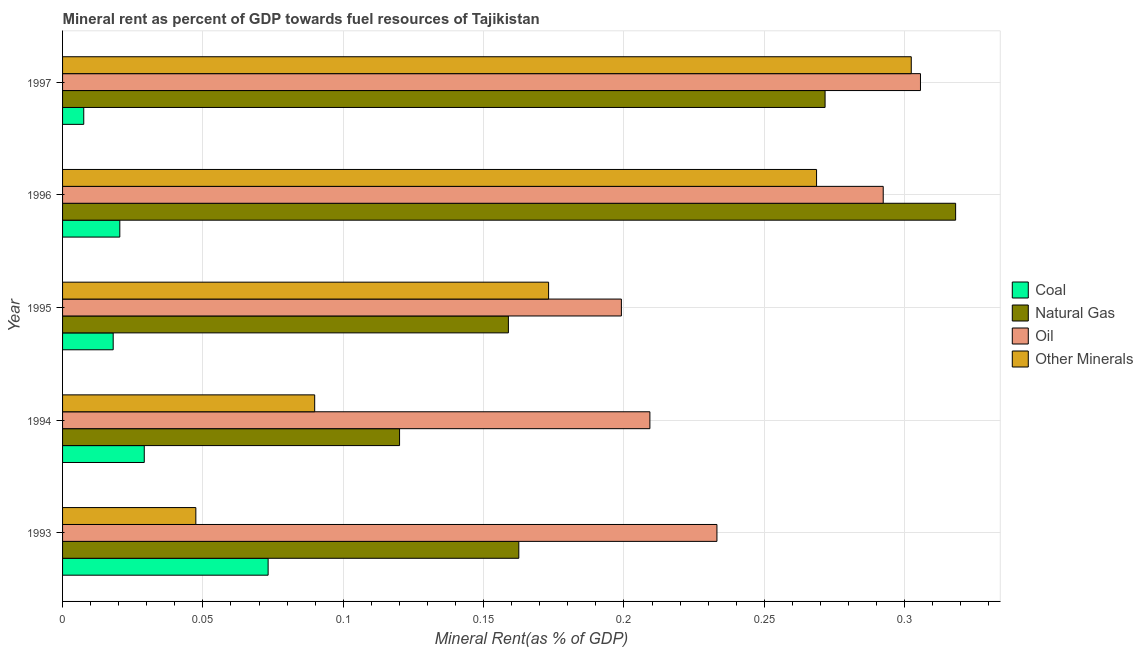How many groups of bars are there?
Your answer should be very brief. 5. Are the number of bars per tick equal to the number of legend labels?
Offer a very short reply. Yes. What is the oil rent in 1994?
Keep it short and to the point. 0.21. Across all years, what is the maximum  rent of other minerals?
Your answer should be very brief. 0.3. Across all years, what is the minimum oil rent?
Provide a succinct answer. 0.2. What is the total coal rent in the graph?
Your response must be concise. 0.15. What is the difference between the  rent of other minerals in 1993 and that in 1997?
Offer a terse response. -0.26. What is the difference between the natural gas rent in 1997 and the coal rent in 1996?
Your answer should be very brief. 0.25. What is the average natural gas rent per year?
Make the answer very short. 0.21. In the year 1997, what is the difference between the  rent of other minerals and natural gas rent?
Give a very brief answer. 0.03. What is the ratio of the natural gas rent in 1996 to that in 1997?
Make the answer very short. 1.17. Is the natural gas rent in 1994 less than that in 1995?
Give a very brief answer. Yes. What is the difference between the highest and the second highest natural gas rent?
Your response must be concise. 0.05. In how many years, is the natural gas rent greater than the average natural gas rent taken over all years?
Offer a very short reply. 2. What does the 3rd bar from the top in 1993 represents?
Your answer should be very brief. Natural Gas. What does the 1st bar from the bottom in 1994 represents?
Offer a terse response. Coal. Is it the case that in every year, the sum of the coal rent and natural gas rent is greater than the oil rent?
Your answer should be very brief. No. How many bars are there?
Your answer should be very brief. 20. Are all the bars in the graph horizontal?
Keep it short and to the point. Yes. How many legend labels are there?
Provide a short and direct response. 4. How are the legend labels stacked?
Make the answer very short. Vertical. What is the title of the graph?
Keep it short and to the point. Mineral rent as percent of GDP towards fuel resources of Tajikistan. Does "Overall level" appear as one of the legend labels in the graph?
Your answer should be compact. No. What is the label or title of the X-axis?
Your response must be concise. Mineral Rent(as % of GDP). What is the Mineral Rent(as % of GDP) of Coal in 1993?
Offer a very short reply. 0.07. What is the Mineral Rent(as % of GDP) in Natural Gas in 1993?
Your answer should be compact. 0.16. What is the Mineral Rent(as % of GDP) of Oil in 1993?
Make the answer very short. 0.23. What is the Mineral Rent(as % of GDP) of Other Minerals in 1993?
Make the answer very short. 0.05. What is the Mineral Rent(as % of GDP) of Coal in 1994?
Your answer should be very brief. 0.03. What is the Mineral Rent(as % of GDP) in Natural Gas in 1994?
Keep it short and to the point. 0.12. What is the Mineral Rent(as % of GDP) of Oil in 1994?
Keep it short and to the point. 0.21. What is the Mineral Rent(as % of GDP) of Other Minerals in 1994?
Offer a terse response. 0.09. What is the Mineral Rent(as % of GDP) of Coal in 1995?
Provide a succinct answer. 0.02. What is the Mineral Rent(as % of GDP) in Natural Gas in 1995?
Your response must be concise. 0.16. What is the Mineral Rent(as % of GDP) in Oil in 1995?
Offer a terse response. 0.2. What is the Mineral Rent(as % of GDP) of Other Minerals in 1995?
Make the answer very short. 0.17. What is the Mineral Rent(as % of GDP) of Coal in 1996?
Keep it short and to the point. 0.02. What is the Mineral Rent(as % of GDP) in Natural Gas in 1996?
Make the answer very short. 0.32. What is the Mineral Rent(as % of GDP) of Oil in 1996?
Ensure brevity in your answer.  0.29. What is the Mineral Rent(as % of GDP) in Other Minerals in 1996?
Your answer should be compact. 0.27. What is the Mineral Rent(as % of GDP) in Coal in 1997?
Your answer should be very brief. 0.01. What is the Mineral Rent(as % of GDP) of Natural Gas in 1997?
Keep it short and to the point. 0.27. What is the Mineral Rent(as % of GDP) of Oil in 1997?
Provide a succinct answer. 0.31. What is the Mineral Rent(as % of GDP) in Other Minerals in 1997?
Give a very brief answer. 0.3. Across all years, what is the maximum Mineral Rent(as % of GDP) in Coal?
Give a very brief answer. 0.07. Across all years, what is the maximum Mineral Rent(as % of GDP) of Natural Gas?
Your answer should be very brief. 0.32. Across all years, what is the maximum Mineral Rent(as % of GDP) of Oil?
Make the answer very short. 0.31. Across all years, what is the maximum Mineral Rent(as % of GDP) of Other Minerals?
Offer a terse response. 0.3. Across all years, what is the minimum Mineral Rent(as % of GDP) in Coal?
Your response must be concise. 0.01. Across all years, what is the minimum Mineral Rent(as % of GDP) of Natural Gas?
Provide a short and direct response. 0.12. Across all years, what is the minimum Mineral Rent(as % of GDP) of Oil?
Ensure brevity in your answer.  0.2. Across all years, what is the minimum Mineral Rent(as % of GDP) of Other Minerals?
Keep it short and to the point. 0.05. What is the total Mineral Rent(as % of GDP) in Coal in the graph?
Provide a short and direct response. 0.15. What is the total Mineral Rent(as % of GDP) in Natural Gas in the graph?
Make the answer very short. 1.03. What is the total Mineral Rent(as % of GDP) of Oil in the graph?
Your answer should be very brief. 1.24. What is the total Mineral Rent(as % of GDP) of Other Minerals in the graph?
Your answer should be very brief. 0.88. What is the difference between the Mineral Rent(as % of GDP) of Coal in 1993 and that in 1994?
Ensure brevity in your answer.  0.04. What is the difference between the Mineral Rent(as % of GDP) in Natural Gas in 1993 and that in 1994?
Keep it short and to the point. 0.04. What is the difference between the Mineral Rent(as % of GDP) in Oil in 1993 and that in 1994?
Keep it short and to the point. 0.02. What is the difference between the Mineral Rent(as % of GDP) in Other Minerals in 1993 and that in 1994?
Provide a short and direct response. -0.04. What is the difference between the Mineral Rent(as % of GDP) in Coal in 1993 and that in 1995?
Make the answer very short. 0.06. What is the difference between the Mineral Rent(as % of GDP) of Natural Gas in 1993 and that in 1995?
Ensure brevity in your answer.  0. What is the difference between the Mineral Rent(as % of GDP) of Oil in 1993 and that in 1995?
Provide a short and direct response. 0.03. What is the difference between the Mineral Rent(as % of GDP) of Other Minerals in 1993 and that in 1995?
Provide a short and direct response. -0.13. What is the difference between the Mineral Rent(as % of GDP) of Coal in 1993 and that in 1996?
Offer a very short reply. 0.05. What is the difference between the Mineral Rent(as % of GDP) of Natural Gas in 1993 and that in 1996?
Your answer should be compact. -0.16. What is the difference between the Mineral Rent(as % of GDP) in Oil in 1993 and that in 1996?
Offer a very short reply. -0.06. What is the difference between the Mineral Rent(as % of GDP) in Other Minerals in 1993 and that in 1996?
Offer a very short reply. -0.22. What is the difference between the Mineral Rent(as % of GDP) of Coal in 1993 and that in 1997?
Offer a terse response. 0.07. What is the difference between the Mineral Rent(as % of GDP) of Natural Gas in 1993 and that in 1997?
Your answer should be compact. -0.11. What is the difference between the Mineral Rent(as % of GDP) of Oil in 1993 and that in 1997?
Keep it short and to the point. -0.07. What is the difference between the Mineral Rent(as % of GDP) in Other Minerals in 1993 and that in 1997?
Your response must be concise. -0.25. What is the difference between the Mineral Rent(as % of GDP) of Coal in 1994 and that in 1995?
Your response must be concise. 0.01. What is the difference between the Mineral Rent(as % of GDP) of Natural Gas in 1994 and that in 1995?
Your answer should be compact. -0.04. What is the difference between the Mineral Rent(as % of GDP) of Oil in 1994 and that in 1995?
Keep it short and to the point. 0.01. What is the difference between the Mineral Rent(as % of GDP) of Other Minerals in 1994 and that in 1995?
Offer a terse response. -0.08. What is the difference between the Mineral Rent(as % of GDP) of Coal in 1994 and that in 1996?
Give a very brief answer. 0.01. What is the difference between the Mineral Rent(as % of GDP) in Natural Gas in 1994 and that in 1996?
Ensure brevity in your answer.  -0.2. What is the difference between the Mineral Rent(as % of GDP) in Oil in 1994 and that in 1996?
Offer a terse response. -0.08. What is the difference between the Mineral Rent(as % of GDP) in Other Minerals in 1994 and that in 1996?
Provide a short and direct response. -0.18. What is the difference between the Mineral Rent(as % of GDP) in Coal in 1994 and that in 1997?
Offer a terse response. 0.02. What is the difference between the Mineral Rent(as % of GDP) in Natural Gas in 1994 and that in 1997?
Your answer should be very brief. -0.15. What is the difference between the Mineral Rent(as % of GDP) of Oil in 1994 and that in 1997?
Your answer should be compact. -0.1. What is the difference between the Mineral Rent(as % of GDP) in Other Minerals in 1994 and that in 1997?
Ensure brevity in your answer.  -0.21. What is the difference between the Mineral Rent(as % of GDP) in Coal in 1995 and that in 1996?
Your response must be concise. -0. What is the difference between the Mineral Rent(as % of GDP) of Natural Gas in 1995 and that in 1996?
Offer a very short reply. -0.16. What is the difference between the Mineral Rent(as % of GDP) in Oil in 1995 and that in 1996?
Offer a very short reply. -0.09. What is the difference between the Mineral Rent(as % of GDP) in Other Minerals in 1995 and that in 1996?
Make the answer very short. -0.1. What is the difference between the Mineral Rent(as % of GDP) of Coal in 1995 and that in 1997?
Give a very brief answer. 0.01. What is the difference between the Mineral Rent(as % of GDP) in Natural Gas in 1995 and that in 1997?
Make the answer very short. -0.11. What is the difference between the Mineral Rent(as % of GDP) in Oil in 1995 and that in 1997?
Keep it short and to the point. -0.11. What is the difference between the Mineral Rent(as % of GDP) of Other Minerals in 1995 and that in 1997?
Offer a very short reply. -0.13. What is the difference between the Mineral Rent(as % of GDP) of Coal in 1996 and that in 1997?
Offer a terse response. 0.01. What is the difference between the Mineral Rent(as % of GDP) in Natural Gas in 1996 and that in 1997?
Provide a succinct answer. 0.05. What is the difference between the Mineral Rent(as % of GDP) of Oil in 1996 and that in 1997?
Your answer should be compact. -0.01. What is the difference between the Mineral Rent(as % of GDP) in Other Minerals in 1996 and that in 1997?
Ensure brevity in your answer.  -0.03. What is the difference between the Mineral Rent(as % of GDP) in Coal in 1993 and the Mineral Rent(as % of GDP) in Natural Gas in 1994?
Offer a terse response. -0.05. What is the difference between the Mineral Rent(as % of GDP) of Coal in 1993 and the Mineral Rent(as % of GDP) of Oil in 1994?
Your answer should be very brief. -0.14. What is the difference between the Mineral Rent(as % of GDP) of Coal in 1993 and the Mineral Rent(as % of GDP) of Other Minerals in 1994?
Offer a very short reply. -0.02. What is the difference between the Mineral Rent(as % of GDP) in Natural Gas in 1993 and the Mineral Rent(as % of GDP) in Oil in 1994?
Your answer should be compact. -0.05. What is the difference between the Mineral Rent(as % of GDP) of Natural Gas in 1993 and the Mineral Rent(as % of GDP) of Other Minerals in 1994?
Offer a very short reply. 0.07. What is the difference between the Mineral Rent(as % of GDP) in Oil in 1993 and the Mineral Rent(as % of GDP) in Other Minerals in 1994?
Your answer should be compact. 0.14. What is the difference between the Mineral Rent(as % of GDP) of Coal in 1993 and the Mineral Rent(as % of GDP) of Natural Gas in 1995?
Give a very brief answer. -0.09. What is the difference between the Mineral Rent(as % of GDP) of Coal in 1993 and the Mineral Rent(as % of GDP) of Oil in 1995?
Your answer should be compact. -0.13. What is the difference between the Mineral Rent(as % of GDP) of Coal in 1993 and the Mineral Rent(as % of GDP) of Other Minerals in 1995?
Provide a short and direct response. -0.1. What is the difference between the Mineral Rent(as % of GDP) in Natural Gas in 1993 and the Mineral Rent(as % of GDP) in Oil in 1995?
Offer a terse response. -0.04. What is the difference between the Mineral Rent(as % of GDP) in Natural Gas in 1993 and the Mineral Rent(as % of GDP) in Other Minerals in 1995?
Your answer should be very brief. -0.01. What is the difference between the Mineral Rent(as % of GDP) of Oil in 1993 and the Mineral Rent(as % of GDP) of Other Minerals in 1995?
Make the answer very short. 0.06. What is the difference between the Mineral Rent(as % of GDP) in Coal in 1993 and the Mineral Rent(as % of GDP) in Natural Gas in 1996?
Provide a short and direct response. -0.24. What is the difference between the Mineral Rent(as % of GDP) in Coal in 1993 and the Mineral Rent(as % of GDP) in Oil in 1996?
Your answer should be very brief. -0.22. What is the difference between the Mineral Rent(as % of GDP) in Coal in 1993 and the Mineral Rent(as % of GDP) in Other Minerals in 1996?
Offer a terse response. -0.2. What is the difference between the Mineral Rent(as % of GDP) in Natural Gas in 1993 and the Mineral Rent(as % of GDP) in Oil in 1996?
Provide a succinct answer. -0.13. What is the difference between the Mineral Rent(as % of GDP) of Natural Gas in 1993 and the Mineral Rent(as % of GDP) of Other Minerals in 1996?
Your response must be concise. -0.11. What is the difference between the Mineral Rent(as % of GDP) of Oil in 1993 and the Mineral Rent(as % of GDP) of Other Minerals in 1996?
Make the answer very short. -0.04. What is the difference between the Mineral Rent(as % of GDP) in Coal in 1993 and the Mineral Rent(as % of GDP) in Natural Gas in 1997?
Ensure brevity in your answer.  -0.2. What is the difference between the Mineral Rent(as % of GDP) of Coal in 1993 and the Mineral Rent(as % of GDP) of Oil in 1997?
Make the answer very short. -0.23. What is the difference between the Mineral Rent(as % of GDP) of Coal in 1993 and the Mineral Rent(as % of GDP) of Other Minerals in 1997?
Offer a terse response. -0.23. What is the difference between the Mineral Rent(as % of GDP) of Natural Gas in 1993 and the Mineral Rent(as % of GDP) of Oil in 1997?
Your response must be concise. -0.14. What is the difference between the Mineral Rent(as % of GDP) in Natural Gas in 1993 and the Mineral Rent(as % of GDP) in Other Minerals in 1997?
Keep it short and to the point. -0.14. What is the difference between the Mineral Rent(as % of GDP) of Oil in 1993 and the Mineral Rent(as % of GDP) of Other Minerals in 1997?
Provide a succinct answer. -0.07. What is the difference between the Mineral Rent(as % of GDP) in Coal in 1994 and the Mineral Rent(as % of GDP) in Natural Gas in 1995?
Offer a terse response. -0.13. What is the difference between the Mineral Rent(as % of GDP) of Coal in 1994 and the Mineral Rent(as % of GDP) of Oil in 1995?
Your answer should be very brief. -0.17. What is the difference between the Mineral Rent(as % of GDP) of Coal in 1994 and the Mineral Rent(as % of GDP) of Other Minerals in 1995?
Provide a short and direct response. -0.14. What is the difference between the Mineral Rent(as % of GDP) of Natural Gas in 1994 and the Mineral Rent(as % of GDP) of Oil in 1995?
Provide a short and direct response. -0.08. What is the difference between the Mineral Rent(as % of GDP) in Natural Gas in 1994 and the Mineral Rent(as % of GDP) in Other Minerals in 1995?
Offer a very short reply. -0.05. What is the difference between the Mineral Rent(as % of GDP) of Oil in 1994 and the Mineral Rent(as % of GDP) of Other Minerals in 1995?
Offer a very short reply. 0.04. What is the difference between the Mineral Rent(as % of GDP) of Coal in 1994 and the Mineral Rent(as % of GDP) of Natural Gas in 1996?
Provide a succinct answer. -0.29. What is the difference between the Mineral Rent(as % of GDP) in Coal in 1994 and the Mineral Rent(as % of GDP) in Oil in 1996?
Offer a very short reply. -0.26. What is the difference between the Mineral Rent(as % of GDP) of Coal in 1994 and the Mineral Rent(as % of GDP) of Other Minerals in 1996?
Your answer should be very brief. -0.24. What is the difference between the Mineral Rent(as % of GDP) in Natural Gas in 1994 and the Mineral Rent(as % of GDP) in Oil in 1996?
Give a very brief answer. -0.17. What is the difference between the Mineral Rent(as % of GDP) in Natural Gas in 1994 and the Mineral Rent(as % of GDP) in Other Minerals in 1996?
Offer a very short reply. -0.15. What is the difference between the Mineral Rent(as % of GDP) of Oil in 1994 and the Mineral Rent(as % of GDP) of Other Minerals in 1996?
Your answer should be very brief. -0.06. What is the difference between the Mineral Rent(as % of GDP) in Coal in 1994 and the Mineral Rent(as % of GDP) in Natural Gas in 1997?
Your answer should be compact. -0.24. What is the difference between the Mineral Rent(as % of GDP) of Coal in 1994 and the Mineral Rent(as % of GDP) of Oil in 1997?
Keep it short and to the point. -0.28. What is the difference between the Mineral Rent(as % of GDP) of Coal in 1994 and the Mineral Rent(as % of GDP) of Other Minerals in 1997?
Give a very brief answer. -0.27. What is the difference between the Mineral Rent(as % of GDP) in Natural Gas in 1994 and the Mineral Rent(as % of GDP) in Oil in 1997?
Your response must be concise. -0.19. What is the difference between the Mineral Rent(as % of GDP) of Natural Gas in 1994 and the Mineral Rent(as % of GDP) of Other Minerals in 1997?
Your answer should be very brief. -0.18. What is the difference between the Mineral Rent(as % of GDP) in Oil in 1994 and the Mineral Rent(as % of GDP) in Other Minerals in 1997?
Give a very brief answer. -0.09. What is the difference between the Mineral Rent(as % of GDP) of Coal in 1995 and the Mineral Rent(as % of GDP) of Natural Gas in 1996?
Your answer should be very brief. -0.3. What is the difference between the Mineral Rent(as % of GDP) of Coal in 1995 and the Mineral Rent(as % of GDP) of Oil in 1996?
Provide a short and direct response. -0.27. What is the difference between the Mineral Rent(as % of GDP) of Coal in 1995 and the Mineral Rent(as % of GDP) of Other Minerals in 1996?
Offer a terse response. -0.25. What is the difference between the Mineral Rent(as % of GDP) of Natural Gas in 1995 and the Mineral Rent(as % of GDP) of Oil in 1996?
Provide a short and direct response. -0.13. What is the difference between the Mineral Rent(as % of GDP) of Natural Gas in 1995 and the Mineral Rent(as % of GDP) of Other Minerals in 1996?
Ensure brevity in your answer.  -0.11. What is the difference between the Mineral Rent(as % of GDP) in Oil in 1995 and the Mineral Rent(as % of GDP) in Other Minerals in 1996?
Make the answer very short. -0.07. What is the difference between the Mineral Rent(as % of GDP) of Coal in 1995 and the Mineral Rent(as % of GDP) of Natural Gas in 1997?
Your answer should be compact. -0.25. What is the difference between the Mineral Rent(as % of GDP) in Coal in 1995 and the Mineral Rent(as % of GDP) in Oil in 1997?
Offer a terse response. -0.29. What is the difference between the Mineral Rent(as % of GDP) of Coal in 1995 and the Mineral Rent(as % of GDP) of Other Minerals in 1997?
Your answer should be very brief. -0.28. What is the difference between the Mineral Rent(as % of GDP) in Natural Gas in 1995 and the Mineral Rent(as % of GDP) in Oil in 1997?
Keep it short and to the point. -0.15. What is the difference between the Mineral Rent(as % of GDP) in Natural Gas in 1995 and the Mineral Rent(as % of GDP) in Other Minerals in 1997?
Offer a terse response. -0.14. What is the difference between the Mineral Rent(as % of GDP) in Oil in 1995 and the Mineral Rent(as % of GDP) in Other Minerals in 1997?
Your answer should be very brief. -0.1. What is the difference between the Mineral Rent(as % of GDP) of Coal in 1996 and the Mineral Rent(as % of GDP) of Natural Gas in 1997?
Ensure brevity in your answer.  -0.25. What is the difference between the Mineral Rent(as % of GDP) in Coal in 1996 and the Mineral Rent(as % of GDP) in Oil in 1997?
Your answer should be very brief. -0.29. What is the difference between the Mineral Rent(as % of GDP) in Coal in 1996 and the Mineral Rent(as % of GDP) in Other Minerals in 1997?
Offer a terse response. -0.28. What is the difference between the Mineral Rent(as % of GDP) in Natural Gas in 1996 and the Mineral Rent(as % of GDP) in Oil in 1997?
Offer a very short reply. 0.01. What is the difference between the Mineral Rent(as % of GDP) of Natural Gas in 1996 and the Mineral Rent(as % of GDP) of Other Minerals in 1997?
Provide a succinct answer. 0.02. What is the difference between the Mineral Rent(as % of GDP) of Oil in 1996 and the Mineral Rent(as % of GDP) of Other Minerals in 1997?
Your response must be concise. -0.01. What is the average Mineral Rent(as % of GDP) in Coal per year?
Your answer should be compact. 0.03. What is the average Mineral Rent(as % of GDP) in Natural Gas per year?
Make the answer very short. 0.21. What is the average Mineral Rent(as % of GDP) in Oil per year?
Give a very brief answer. 0.25. What is the average Mineral Rent(as % of GDP) in Other Minerals per year?
Make the answer very short. 0.18. In the year 1993, what is the difference between the Mineral Rent(as % of GDP) of Coal and Mineral Rent(as % of GDP) of Natural Gas?
Offer a terse response. -0.09. In the year 1993, what is the difference between the Mineral Rent(as % of GDP) in Coal and Mineral Rent(as % of GDP) in Oil?
Give a very brief answer. -0.16. In the year 1993, what is the difference between the Mineral Rent(as % of GDP) in Coal and Mineral Rent(as % of GDP) in Other Minerals?
Make the answer very short. 0.03. In the year 1993, what is the difference between the Mineral Rent(as % of GDP) of Natural Gas and Mineral Rent(as % of GDP) of Oil?
Provide a succinct answer. -0.07. In the year 1993, what is the difference between the Mineral Rent(as % of GDP) in Natural Gas and Mineral Rent(as % of GDP) in Other Minerals?
Provide a short and direct response. 0.12. In the year 1993, what is the difference between the Mineral Rent(as % of GDP) of Oil and Mineral Rent(as % of GDP) of Other Minerals?
Your answer should be very brief. 0.19. In the year 1994, what is the difference between the Mineral Rent(as % of GDP) in Coal and Mineral Rent(as % of GDP) in Natural Gas?
Your answer should be very brief. -0.09. In the year 1994, what is the difference between the Mineral Rent(as % of GDP) of Coal and Mineral Rent(as % of GDP) of Oil?
Offer a terse response. -0.18. In the year 1994, what is the difference between the Mineral Rent(as % of GDP) in Coal and Mineral Rent(as % of GDP) in Other Minerals?
Your answer should be compact. -0.06. In the year 1994, what is the difference between the Mineral Rent(as % of GDP) in Natural Gas and Mineral Rent(as % of GDP) in Oil?
Ensure brevity in your answer.  -0.09. In the year 1994, what is the difference between the Mineral Rent(as % of GDP) of Natural Gas and Mineral Rent(as % of GDP) of Other Minerals?
Your answer should be very brief. 0.03. In the year 1994, what is the difference between the Mineral Rent(as % of GDP) of Oil and Mineral Rent(as % of GDP) of Other Minerals?
Provide a short and direct response. 0.12. In the year 1995, what is the difference between the Mineral Rent(as % of GDP) of Coal and Mineral Rent(as % of GDP) of Natural Gas?
Offer a very short reply. -0.14. In the year 1995, what is the difference between the Mineral Rent(as % of GDP) in Coal and Mineral Rent(as % of GDP) in Oil?
Provide a short and direct response. -0.18. In the year 1995, what is the difference between the Mineral Rent(as % of GDP) in Coal and Mineral Rent(as % of GDP) in Other Minerals?
Give a very brief answer. -0.16. In the year 1995, what is the difference between the Mineral Rent(as % of GDP) of Natural Gas and Mineral Rent(as % of GDP) of Oil?
Offer a terse response. -0.04. In the year 1995, what is the difference between the Mineral Rent(as % of GDP) in Natural Gas and Mineral Rent(as % of GDP) in Other Minerals?
Ensure brevity in your answer.  -0.01. In the year 1995, what is the difference between the Mineral Rent(as % of GDP) of Oil and Mineral Rent(as % of GDP) of Other Minerals?
Your response must be concise. 0.03. In the year 1996, what is the difference between the Mineral Rent(as % of GDP) of Coal and Mineral Rent(as % of GDP) of Natural Gas?
Ensure brevity in your answer.  -0.3. In the year 1996, what is the difference between the Mineral Rent(as % of GDP) of Coal and Mineral Rent(as % of GDP) of Oil?
Provide a short and direct response. -0.27. In the year 1996, what is the difference between the Mineral Rent(as % of GDP) of Coal and Mineral Rent(as % of GDP) of Other Minerals?
Offer a terse response. -0.25. In the year 1996, what is the difference between the Mineral Rent(as % of GDP) of Natural Gas and Mineral Rent(as % of GDP) of Oil?
Offer a terse response. 0.03. In the year 1996, what is the difference between the Mineral Rent(as % of GDP) in Natural Gas and Mineral Rent(as % of GDP) in Other Minerals?
Give a very brief answer. 0.05. In the year 1996, what is the difference between the Mineral Rent(as % of GDP) of Oil and Mineral Rent(as % of GDP) of Other Minerals?
Your answer should be compact. 0.02. In the year 1997, what is the difference between the Mineral Rent(as % of GDP) in Coal and Mineral Rent(as % of GDP) in Natural Gas?
Your answer should be compact. -0.26. In the year 1997, what is the difference between the Mineral Rent(as % of GDP) of Coal and Mineral Rent(as % of GDP) of Oil?
Keep it short and to the point. -0.3. In the year 1997, what is the difference between the Mineral Rent(as % of GDP) in Coal and Mineral Rent(as % of GDP) in Other Minerals?
Make the answer very short. -0.29. In the year 1997, what is the difference between the Mineral Rent(as % of GDP) in Natural Gas and Mineral Rent(as % of GDP) in Oil?
Ensure brevity in your answer.  -0.03. In the year 1997, what is the difference between the Mineral Rent(as % of GDP) of Natural Gas and Mineral Rent(as % of GDP) of Other Minerals?
Provide a succinct answer. -0.03. In the year 1997, what is the difference between the Mineral Rent(as % of GDP) of Oil and Mineral Rent(as % of GDP) of Other Minerals?
Your answer should be compact. 0. What is the ratio of the Mineral Rent(as % of GDP) in Coal in 1993 to that in 1994?
Give a very brief answer. 2.52. What is the ratio of the Mineral Rent(as % of GDP) in Natural Gas in 1993 to that in 1994?
Offer a very short reply. 1.35. What is the ratio of the Mineral Rent(as % of GDP) of Oil in 1993 to that in 1994?
Your answer should be very brief. 1.11. What is the ratio of the Mineral Rent(as % of GDP) in Other Minerals in 1993 to that in 1994?
Provide a short and direct response. 0.53. What is the ratio of the Mineral Rent(as % of GDP) of Coal in 1993 to that in 1995?
Keep it short and to the point. 4.06. What is the ratio of the Mineral Rent(as % of GDP) in Natural Gas in 1993 to that in 1995?
Provide a succinct answer. 1.02. What is the ratio of the Mineral Rent(as % of GDP) of Oil in 1993 to that in 1995?
Keep it short and to the point. 1.17. What is the ratio of the Mineral Rent(as % of GDP) in Other Minerals in 1993 to that in 1995?
Give a very brief answer. 0.27. What is the ratio of the Mineral Rent(as % of GDP) of Coal in 1993 to that in 1996?
Give a very brief answer. 3.59. What is the ratio of the Mineral Rent(as % of GDP) of Natural Gas in 1993 to that in 1996?
Your answer should be compact. 0.51. What is the ratio of the Mineral Rent(as % of GDP) in Oil in 1993 to that in 1996?
Keep it short and to the point. 0.8. What is the ratio of the Mineral Rent(as % of GDP) in Other Minerals in 1993 to that in 1996?
Provide a succinct answer. 0.18. What is the ratio of the Mineral Rent(as % of GDP) in Coal in 1993 to that in 1997?
Your response must be concise. 9.71. What is the ratio of the Mineral Rent(as % of GDP) of Natural Gas in 1993 to that in 1997?
Your response must be concise. 0.6. What is the ratio of the Mineral Rent(as % of GDP) in Oil in 1993 to that in 1997?
Your response must be concise. 0.76. What is the ratio of the Mineral Rent(as % of GDP) of Other Minerals in 1993 to that in 1997?
Ensure brevity in your answer.  0.16. What is the ratio of the Mineral Rent(as % of GDP) of Coal in 1994 to that in 1995?
Keep it short and to the point. 1.61. What is the ratio of the Mineral Rent(as % of GDP) of Natural Gas in 1994 to that in 1995?
Offer a very short reply. 0.76. What is the ratio of the Mineral Rent(as % of GDP) of Oil in 1994 to that in 1995?
Ensure brevity in your answer.  1.05. What is the ratio of the Mineral Rent(as % of GDP) of Other Minerals in 1994 to that in 1995?
Ensure brevity in your answer.  0.52. What is the ratio of the Mineral Rent(as % of GDP) in Coal in 1994 to that in 1996?
Your answer should be very brief. 1.43. What is the ratio of the Mineral Rent(as % of GDP) of Natural Gas in 1994 to that in 1996?
Offer a terse response. 0.38. What is the ratio of the Mineral Rent(as % of GDP) of Oil in 1994 to that in 1996?
Keep it short and to the point. 0.72. What is the ratio of the Mineral Rent(as % of GDP) in Other Minerals in 1994 to that in 1996?
Give a very brief answer. 0.33. What is the ratio of the Mineral Rent(as % of GDP) of Coal in 1994 to that in 1997?
Make the answer very short. 3.86. What is the ratio of the Mineral Rent(as % of GDP) of Natural Gas in 1994 to that in 1997?
Your answer should be very brief. 0.44. What is the ratio of the Mineral Rent(as % of GDP) in Oil in 1994 to that in 1997?
Give a very brief answer. 0.68. What is the ratio of the Mineral Rent(as % of GDP) of Other Minerals in 1994 to that in 1997?
Provide a short and direct response. 0.3. What is the ratio of the Mineral Rent(as % of GDP) in Coal in 1995 to that in 1996?
Offer a terse response. 0.88. What is the ratio of the Mineral Rent(as % of GDP) of Natural Gas in 1995 to that in 1996?
Offer a terse response. 0.5. What is the ratio of the Mineral Rent(as % of GDP) in Oil in 1995 to that in 1996?
Your answer should be very brief. 0.68. What is the ratio of the Mineral Rent(as % of GDP) of Other Minerals in 1995 to that in 1996?
Offer a terse response. 0.64. What is the ratio of the Mineral Rent(as % of GDP) in Coal in 1995 to that in 1997?
Your response must be concise. 2.39. What is the ratio of the Mineral Rent(as % of GDP) in Natural Gas in 1995 to that in 1997?
Your answer should be compact. 0.58. What is the ratio of the Mineral Rent(as % of GDP) in Oil in 1995 to that in 1997?
Ensure brevity in your answer.  0.65. What is the ratio of the Mineral Rent(as % of GDP) in Other Minerals in 1995 to that in 1997?
Keep it short and to the point. 0.57. What is the ratio of the Mineral Rent(as % of GDP) in Coal in 1996 to that in 1997?
Your answer should be very brief. 2.7. What is the ratio of the Mineral Rent(as % of GDP) of Natural Gas in 1996 to that in 1997?
Make the answer very short. 1.17. What is the ratio of the Mineral Rent(as % of GDP) in Oil in 1996 to that in 1997?
Ensure brevity in your answer.  0.96. What is the ratio of the Mineral Rent(as % of GDP) of Other Minerals in 1996 to that in 1997?
Provide a succinct answer. 0.89. What is the difference between the highest and the second highest Mineral Rent(as % of GDP) in Coal?
Give a very brief answer. 0.04. What is the difference between the highest and the second highest Mineral Rent(as % of GDP) in Natural Gas?
Give a very brief answer. 0.05. What is the difference between the highest and the second highest Mineral Rent(as % of GDP) of Oil?
Keep it short and to the point. 0.01. What is the difference between the highest and the second highest Mineral Rent(as % of GDP) of Other Minerals?
Your answer should be compact. 0.03. What is the difference between the highest and the lowest Mineral Rent(as % of GDP) of Coal?
Keep it short and to the point. 0.07. What is the difference between the highest and the lowest Mineral Rent(as % of GDP) of Natural Gas?
Your answer should be compact. 0.2. What is the difference between the highest and the lowest Mineral Rent(as % of GDP) of Oil?
Give a very brief answer. 0.11. What is the difference between the highest and the lowest Mineral Rent(as % of GDP) in Other Minerals?
Give a very brief answer. 0.25. 